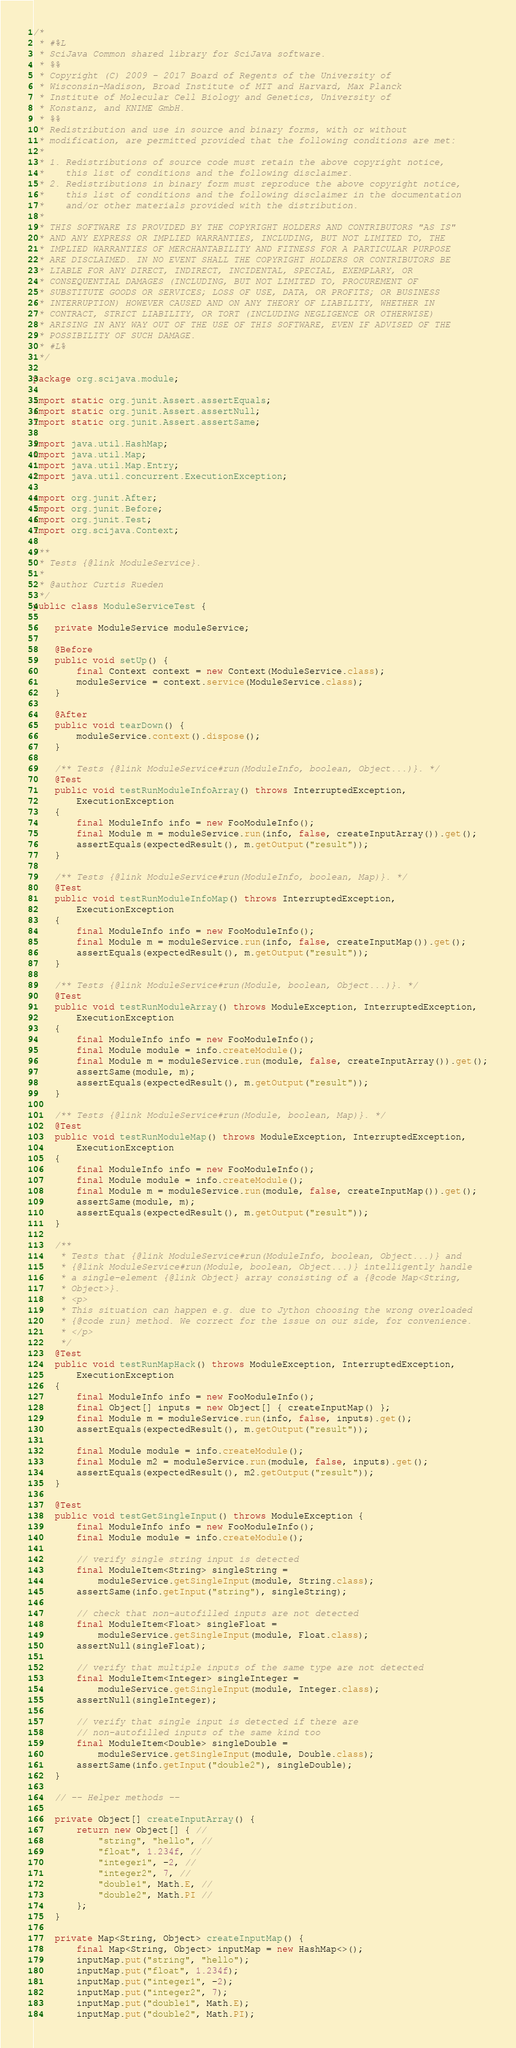<code> <loc_0><loc_0><loc_500><loc_500><_Java_>/*
 * #%L
 * SciJava Common shared library for SciJava software.
 * %%
 * Copyright (C) 2009 - 2017 Board of Regents of the University of
 * Wisconsin-Madison, Broad Institute of MIT and Harvard, Max Planck
 * Institute of Molecular Cell Biology and Genetics, University of
 * Konstanz, and KNIME GmbH.
 * %%
 * Redistribution and use in source and binary forms, with or without
 * modification, are permitted provided that the following conditions are met:
 * 
 * 1. Redistributions of source code must retain the above copyright notice,
 *    this list of conditions and the following disclaimer.
 * 2. Redistributions in binary form must reproduce the above copyright notice,
 *    this list of conditions and the following disclaimer in the documentation
 *    and/or other materials provided with the distribution.
 * 
 * THIS SOFTWARE IS PROVIDED BY THE COPYRIGHT HOLDERS AND CONTRIBUTORS "AS IS"
 * AND ANY EXPRESS OR IMPLIED WARRANTIES, INCLUDING, BUT NOT LIMITED TO, THE
 * IMPLIED WARRANTIES OF MERCHANTABILITY AND FITNESS FOR A PARTICULAR PURPOSE
 * ARE DISCLAIMED. IN NO EVENT SHALL THE COPYRIGHT HOLDERS OR CONTRIBUTORS BE
 * LIABLE FOR ANY DIRECT, INDIRECT, INCIDENTAL, SPECIAL, EXEMPLARY, OR
 * CONSEQUENTIAL DAMAGES (INCLUDING, BUT NOT LIMITED TO, PROCUREMENT OF
 * SUBSTITUTE GOODS OR SERVICES; LOSS OF USE, DATA, OR PROFITS; OR BUSINESS
 * INTERRUPTION) HOWEVER CAUSED AND ON ANY THEORY OF LIABILITY, WHETHER IN
 * CONTRACT, STRICT LIABILITY, OR TORT (INCLUDING NEGLIGENCE OR OTHERWISE)
 * ARISING IN ANY WAY OUT OF THE USE OF THIS SOFTWARE, EVEN IF ADVISED OF THE
 * POSSIBILITY OF SUCH DAMAGE.
 * #L%
 */

package org.scijava.module;

import static org.junit.Assert.assertEquals;
import static org.junit.Assert.assertNull;
import static org.junit.Assert.assertSame;

import java.util.HashMap;
import java.util.Map;
import java.util.Map.Entry;
import java.util.concurrent.ExecutionException;

import org.junit.After;
import org.junit.Before;
import org.junit.Test;
import org.scijava.Context;

/**
 * Tests {@link ModuleService}.
 * 
 * @author Curtis Rueden
 */
public class ModuleServiceTest {

	private ModuleService moduleService;

	@Before
	public void setUp() {
		final Context context = new Context(ModuleService.class);
		moduleService = context.service(ModuleService.class);
	}

	@After
	public void tearDown() {
		moduleService.context().dispose();
	}

	/** Tests {@link ModuleService#run(ModuleInfo, boolean, Object...)}. */
	@Test
	public void testRunModuleInfoArray() throws InterruptedException,
		ExecutionException
	{
		final ModuleInfo info = new FooModuleInfo();
		final Module m = moduleService.run(info, false, createInputArray()).get();
		assertEquals(expectedResult(), m.getOutput("result"));
	}

	/** Tests {@link ModuleService#run(ModuleInfo, boolean, Map)}. */
	@Test
	public void testRunModuleInfoMap() throws InterruptedException,
		ExecutionException
	{
		final ModuleInfo info = new FooModuleInfo();
		final Module m = moduleService.run(info, false, createInputMap()).get();
		assertEquals(expectedResult(), m.getOutput("result"));
	}

	/** Tests {@link ModuleService#run(Module, boolean, Object...)}. */
	@Test
	public void testRunModuleArray() throws ModuleException, InterruptedException,
		ExecutionException
	{
		final ModuleInfo info = new FooModuleInfo();
		final Module module = info.createModule();
		final Module m = moduleService.run(module, false, createInputArray()).get();
		assertSame(module, m);
		assertEquals(expectedResult(), m.getOutput("result"));
	}

	/** Tests {@link ModuleService#run(Module, boolean, Map)}. */
	@Test
	public void testRunModuleMap() throws ModuleException, InterruptedException,
		ExecutionException
	{
		final ModuleInfo info = new FooModuleInfo();
		final Module module = info.createModule();
		final Module m = moduleService.run(module, false, createInputMap()).get();
		assertSame(module, m);
		assertEquals(expectedResult(), m.getOutput("result"));
	}

	/**
	 * Tests that {@link ModuleService#run(ModuleInfo, boolean, Object...)} and
	 * {@link ModuleService#run(Module, boolean, Object...)} intelligently handle
	 * a single-element {@link Object} array consisting of a {@code Map<String,
	 * Object>}.
	 * <p>
	 * This situation can happen e.g. due to Jython choosing the wrong overloaded
	 * {@code run} method. We correct for the issue on our side, for convenience.
	 * </p>
	 */
	@Test
	public void testRunMapHack() throws ModuleException, InterruptedException,
		ExecutionException
	{
		final ModuleInfo info = new FooModuleInfo();
		final Object[] inputs = new Object[] { createInputMap() };
		final Module m = moduleService.run(info, false, inputs).get();
		assertEquals(expectedResult(), m.getOutput("result"));

		final Module module = info.createModule();
		final Module m2 = moduleService.run(module, false, inputs).get();
		assertEquals(expectedResult(), m2.getOutput("result"));
	}

	@Test
	public void testGetSingleInput() throws ModuleException {
		final ModuleInfo info = new FooModuleInfo();
		final Module module = info.createModule();

		// verify single string input is detected
		final ModuleItem<String> singleString =
			moduleService.getSingleInput(module, String.class);
		assertSame(info.getInput("string"), singleString);

		// check that non-autofilled inputs are not detected
		final ModuleItem<Float> singleFloat =
			moduleService.getSingleInput(module, Float.class);
		assertNull(singleFloat);

		// verify that multiple inputs of the same type are not detected
		final ModuleItem<Integer> singleInteger =
			moduleService.getSingleInput(module, Integer.class);
		assertNull(singleInteger);

		// verify that single input is detected if there are
		// non-autofilled inputs of the same kind too
		final ModuleItem<Double> singleDouble =
			moduleService.getSingleInput(module, Double.class);
		assertSame(info.getInput("double2"), singleDouble);
	}

	// -- Helper methods --

	private Object[] createInputArray() {
		return new Object[] { //
			"string", "hello", //
			"float", 1.234f, //
			"integer1", -2, //
			"integer2", 7, //
			"double1", Math.E, //
			"double2", Math.PI //
		};
	}

	private Map<String, Object> createInputMap() {
		final Map<String, Object> inputMap = new HashMap<>();
		inputMap.put("string", "hello");
		inputMap.put("float", 1.234f);
		inputMap.put("integer1", -2);
		inputMap.put("integer2", 7);
		inputMap.put("double1", Math.E);
		inputMap.put("double2", Math.PI);</code> 